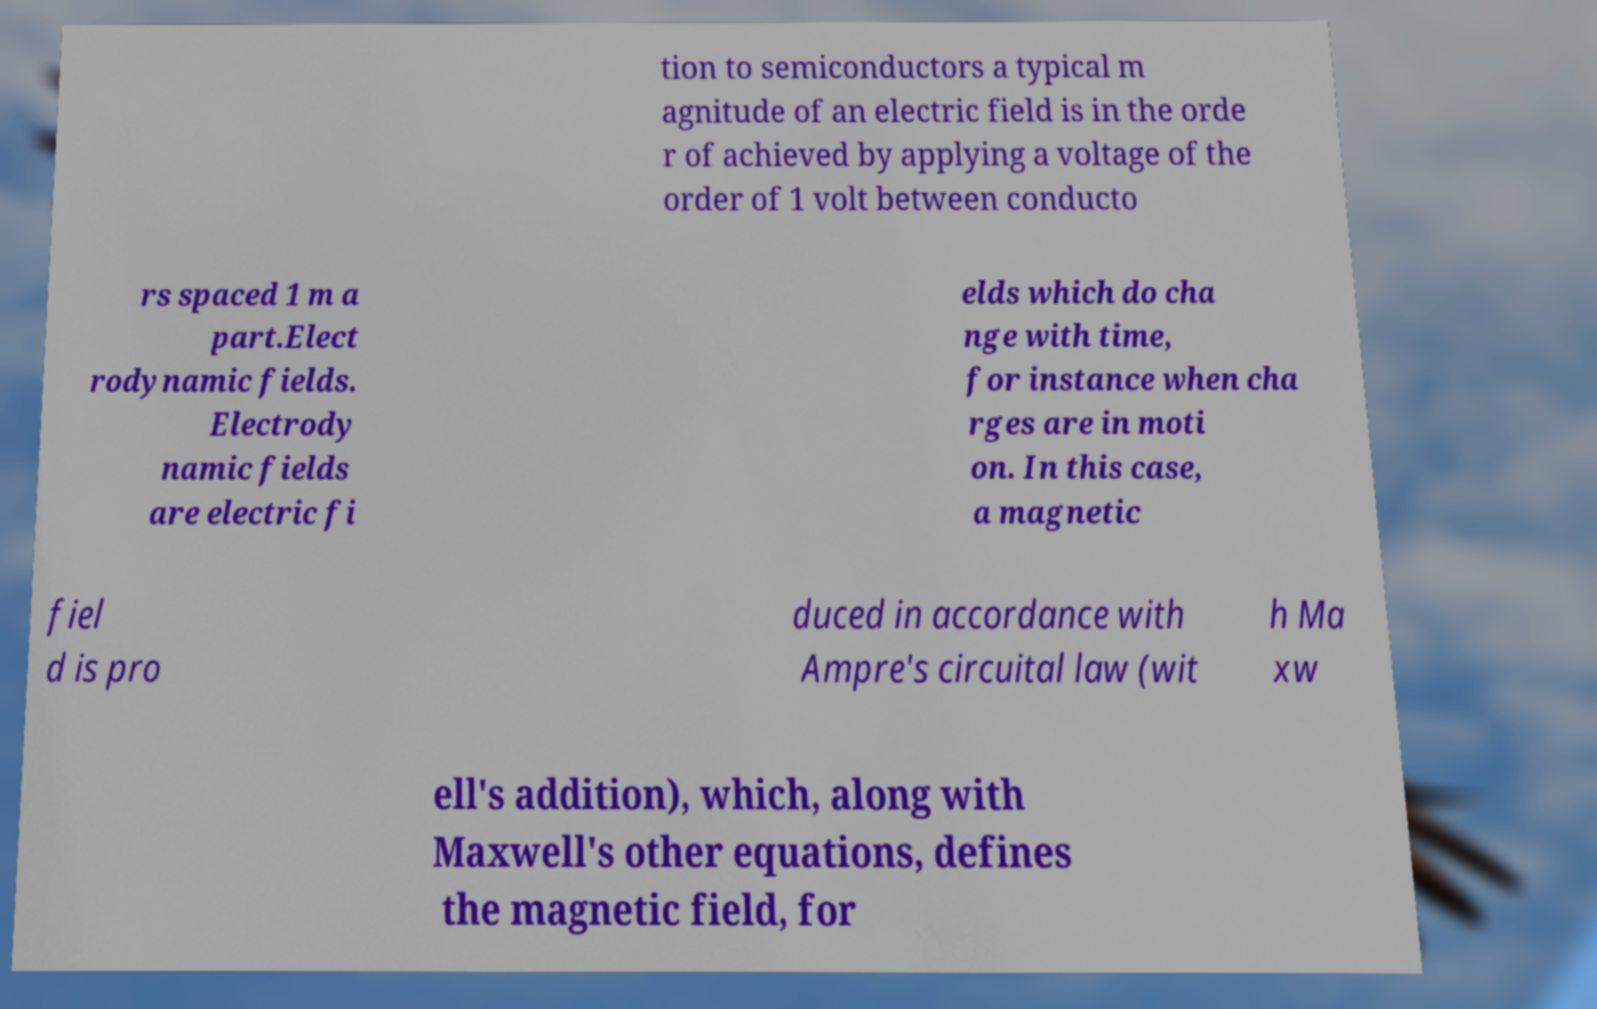For documentation purposes, I need the text within this image transcribed. Could you provide that? tion to semiconductors a typical m agnitude of an electric field is in the orde r of achieved by applying a voltage of the order of 1 volt between conducto rs spaced 1 m a part.Elect rodynamic fields. Electrody namic fields are electric fi elds which do cha nge with time, for instance when cha rges are in moti on. In this case, a magnetic fiel d is pro duced in accordance with Ampre's circuital law (wit h Ma xw ell's addition), which, along with Maxwell's other equations, defines the magnetic field, for 